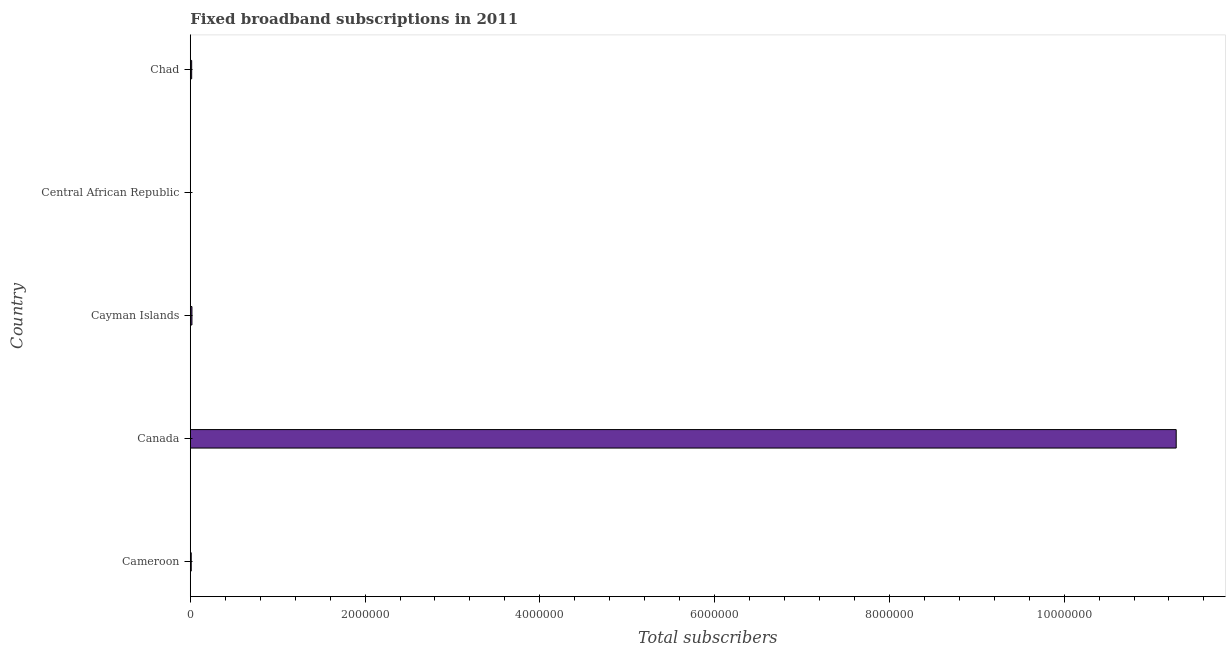What is the title of the graph?
Provide a short and direct response. Fixed broadband subscriptions in 2011. What is the label or title of the X-axis?
Your answer should be compact. Total subscribers. What is the total number of fixed broadband subscriptions in Chad?
Ensure brevity in your answer.  1.58e+04. Across all countries, what is the maximum total number of fixed broadband subscriptions?
Your response must be concise. 1.13e+07. Across all countries, what is the minimum total number of fixed broadband subscriptions?
Provide a succinct answer. 810. In which country was the total number of fixed broadband subscriptions minimum?
Offer a very short reply. Central African Republic. What is the sum of the total number of fixed broadband subscriptions?
Your answer should be very brief. 1.13e+07. What is the difference between the total number of fixed broadband subscriptions in Cameroon and Chad?
Offer a very short reply. -5086. What is the average total number of fixed broadband subscriptions per country?
Give a very brief answer. 2.27e+06. What is the median total number of fixed broadband subscriptions?
Ensure brevity in your answer.  1.58e+04. In how many countries, is the total number of fixed broadband subscriptions greater than 10400000 ?
Offer a very short reply. 1. What is the ratio of the total number of fixed broadband subscriptions in Cameroon to that in Central African Republic?
Your answer should be very brief. 13.23. Is the total number of fixed broadband subscriptions in Canada less than that in Cayman Islands?
Make the answer very short. No. Is the difference between the total number of fixed broadband subscriptions in Cayman Islands and Central African Republic greater than the difference between any two countries?
Offer a very short reply. No. What is the difference between the highest and the second highest total number of fixed broadband subscriptions?
Offer a very short reply. 1.13e+07. What is the difference between the highest and the lowest total number of fixed broadband subscriptions?
Provide a succinct answer. 1.13e+07. In how many countries, is the total number of fixed broadband subscriptions greater than the average total number of fixed broadband subscriptions taken over all countries?
Provide a short and direct response. 1. How many bars are there?
Your answer should be compact. 5. Are all the bars in the graph horizontal?
Offer a very short reply. Yes. How many countries are there in the graph?
Make the answer very short. 5. Are the values on the major ticks of X-axis written in scientific E-notation?
Offer a terse response. No. What is the Total subscribers in Cameroon?
Make the answer very short. 1.07e+04. What is the Total subscribers of Canada?
Provide a succinct answer. 1.13e+07. What is the Total subscribers of Cayman Islands?
Give a very brief answer. 1.88e+04. What is the Total subscribers in Central African Republic?
Keep it short and to the point. 810. What is the Total subscribers in Chad?
Your response must be concise. 1.58e+04. What is the difference between the Total subscribers in Cameroon and Canada?
Provide a succinct answer. -1.13e+07. What is the difference between the Total subscribers in Cameroon and Cayman Islands?
Keep it short and to the point. -8103. What is the difference between the Total subscribers in Cameroon and Central African Republic?
Offer a terse response. 9903. What is the difference between the Total subscribers in Cameroon and Chad?
Make the answer very short. -5086. What is the difference between the Total subscribers in Canada and Cayman Islands?
Make the answer very short. 1.13e+07. What is the difference between the Total subscribers in Canada and Central African Republic?
Your answer should be compact. 1.13e+07. What is the difference between the Total subscribers in Canada and Chad?
Make the answer very short. 1.13e+07. What is the difference between the Total subscribers in Cayman Islands and Central African Republic?
Make the answer very short. 1.80e+04. What is the difference between the Total subscribers in Cayman Islands and Chad?
Offer a terse response. 3017. What is the difference between the Total subscribers in Central African Republic and Chad?
Provide a short and direct response. -1.50e+04. What is the ratio of the Total subscribers in Cameroon to that in Canada?
Your answer should be compact. 0. What is the ratio of the Total subscribers in Cameroon to that in Cayman Islands?
Give a very brief answer. 0.57. What is the ratio of the Total subscribers in Cameroon to that in Central African Republic?
Keep it short and to the point. 13.23. What is the ratio of the Total subscribers in Cameroon to that in Chad?
Your response must be concise. 0.68. What is the ratio of the Total subscribers in Canada to that in Cayman Islands?
Give a very brief answer. 599.63. What is the ratio of the Total subscribers in Canada to that in Central African Republic?
Provide a short and direct response. 1.39e+04. What is the ratio of the Total subscribers in Canada to that in Chad?
Your response must be concise. 714.13. What is the ratio of the Total subscribers in Cayman Islands to that in Central African Republic?
Give a very brief answer. 23.23. What is the ratio of the Total subscribers in Cayman Islands to that in Chad?
Your response must be concise. 1.19. What is the ratio of the Total subscribers in Central African Republic to that in Chad?
Offer a very short reply. 0.05. 